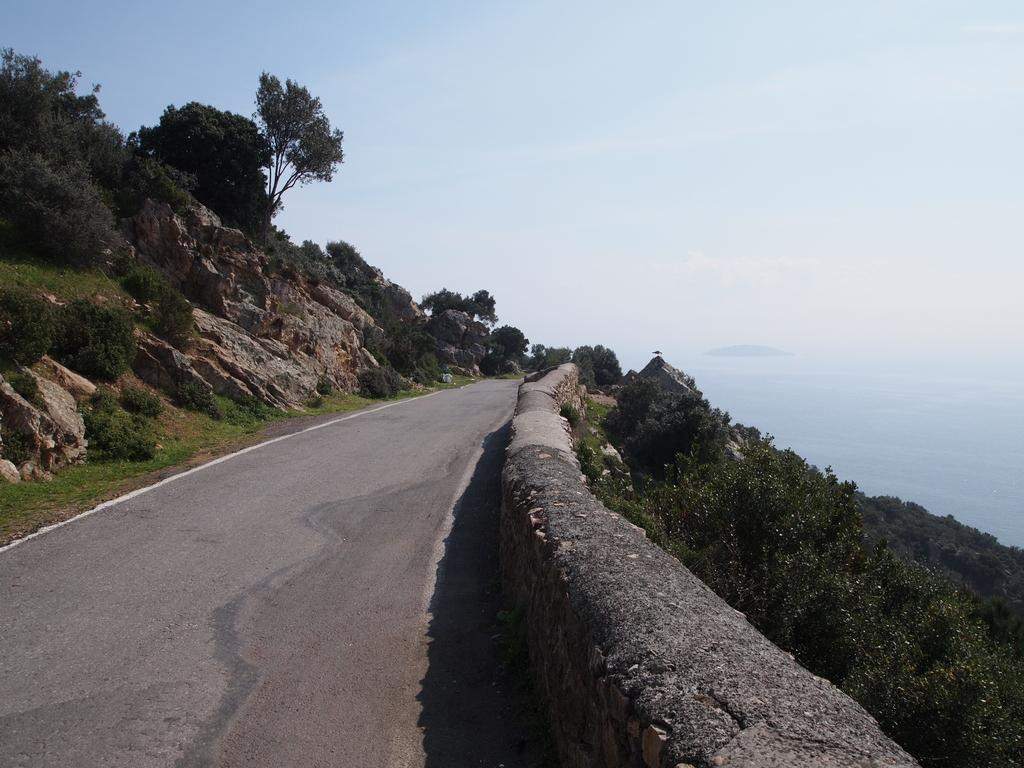What type of barrier can be seen in the image? There is a fence in the image. What type of natural vegetation is present in the image? There are trees in the image. What type of geological formation is visible in the image? There are mountains in the image. What part of the natural environment is visible in the image? The sky is visible in the image. Can you determine the time of day the image was taken? The image appears to be taken during the day. What type of hat is the person wearing in the image? There is no person or hat present in the image. What is your opinion on the scenery depicted in the image? The question about my opinion is not relevant to the image, as we are only discussing the facts present in the image. 